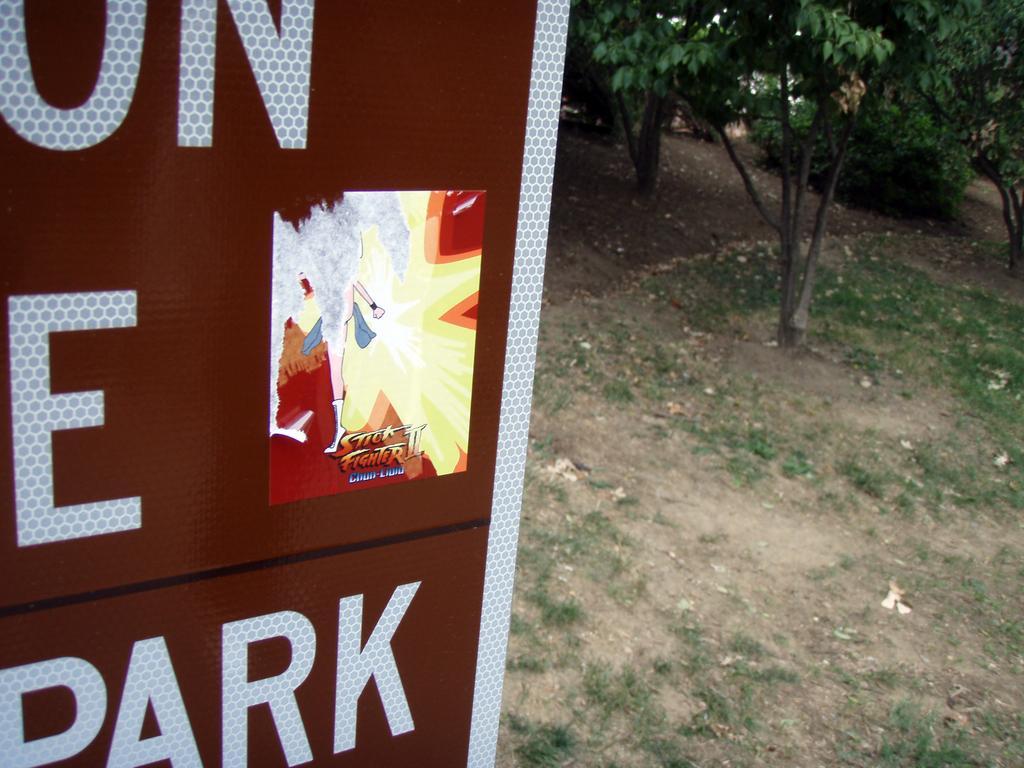How would you summarize this image in a sentence or two? In this image we can see signage board, on right side of the image there are some trees, grass and mud. 